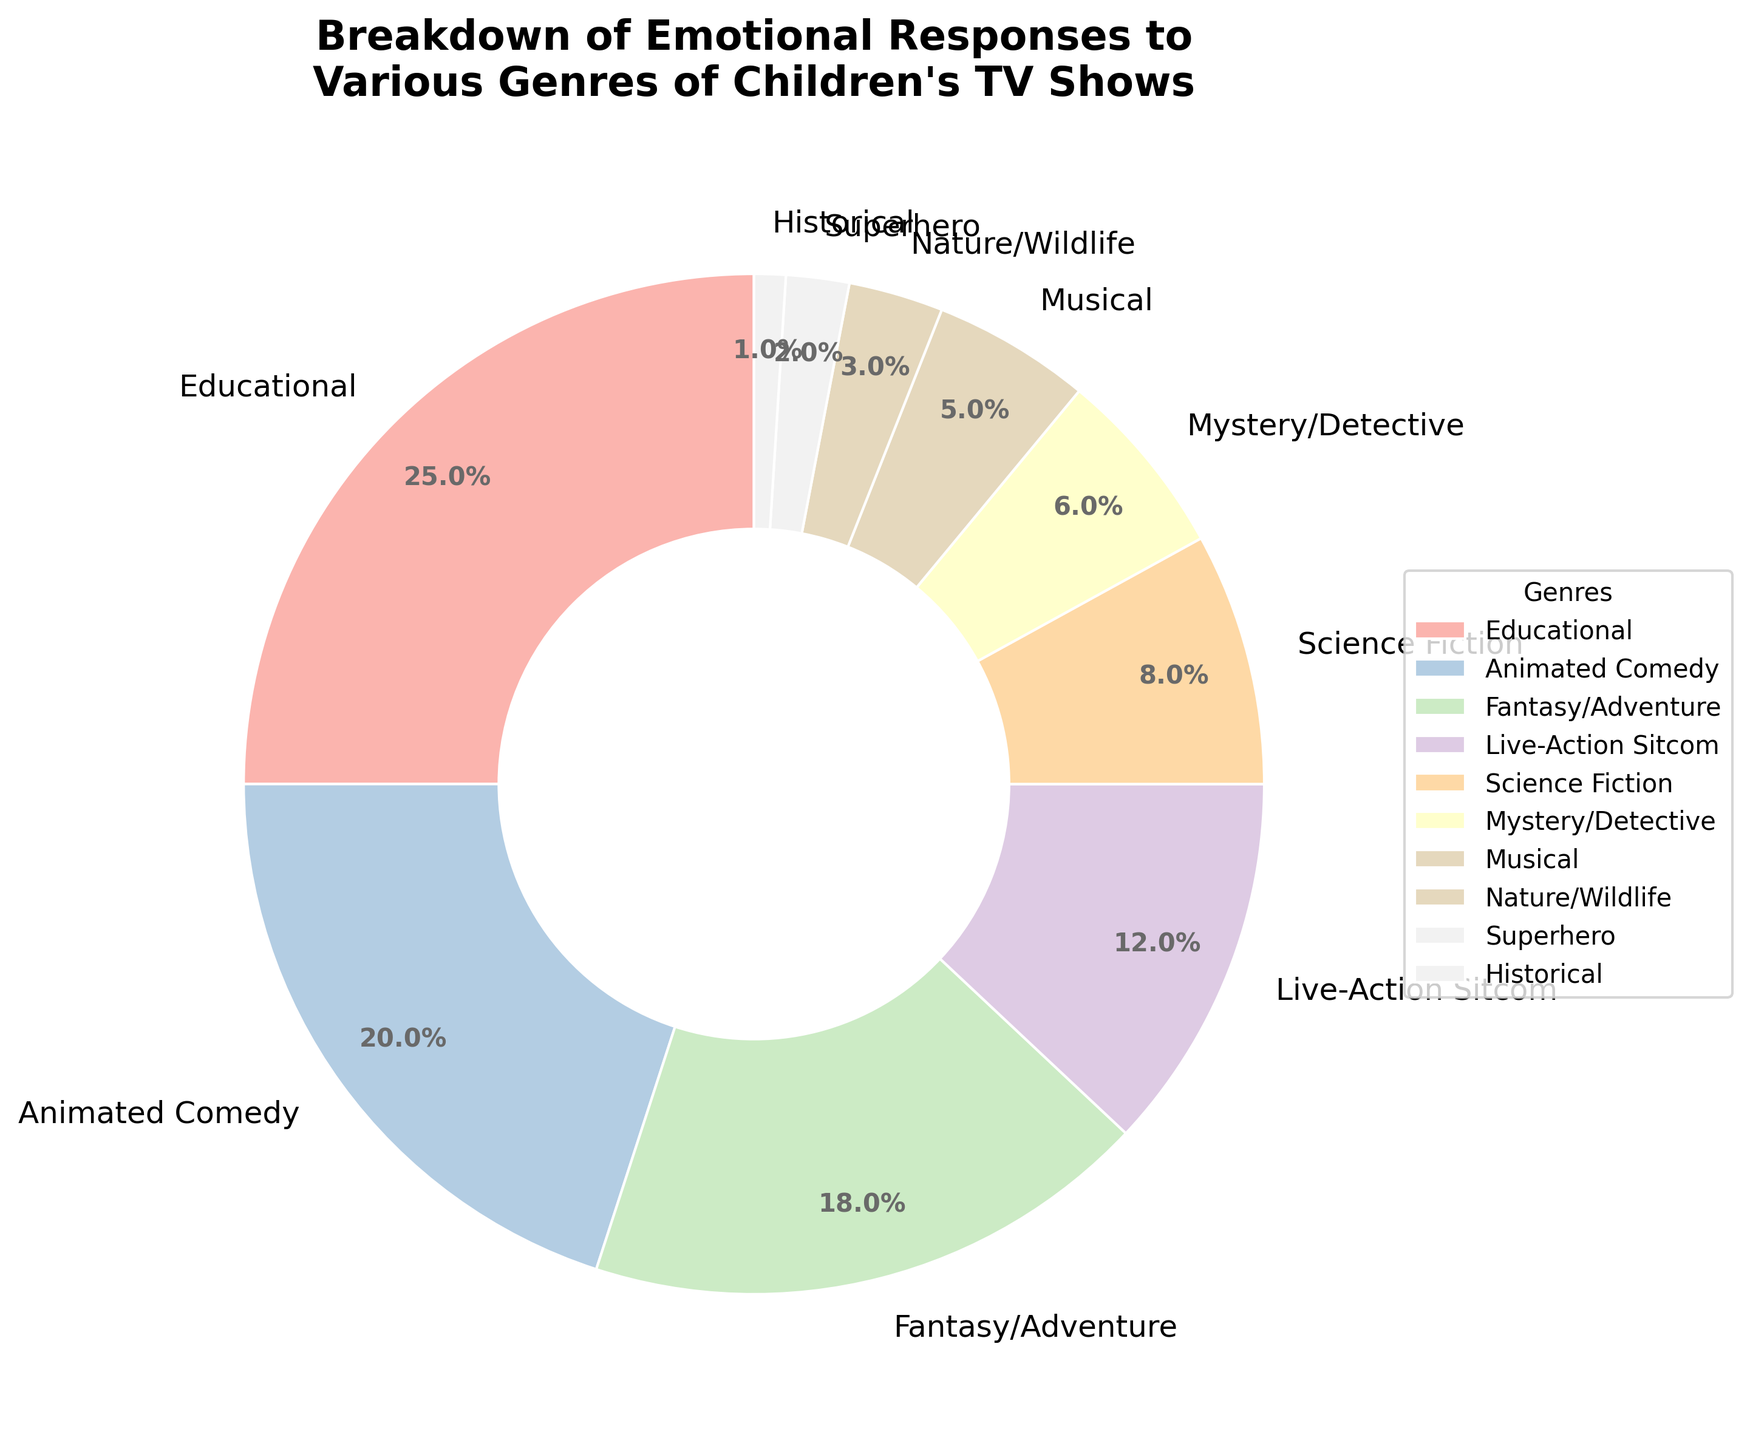What genre has the highest percentage of emotional responses? The pie chart shows the percentages of emotional responses for different genres. The largest wedge represents Educational TV shows.
Answer: Educational What are the top three genres in terms of emotional responses? The chart has wedges representing each genre with different percentages. The three largest wedges correspond to Educational, Animated Comedy, and Fantasy/Adventure.
Answer: Educational, Animated Comedy, Fantasy/Adventure What's the total percentage for the bottom three genres with the least emotional responses? The bottom three genres are Historical, Superhero, and Nature/Wildlife, with percentages of 1%, 2%, and 3% respectively. Summing these percentages: 1 + 2 + 3 = 6.
Answer: 6 Are there more emotional responses to Science Fiction or Live-Action Sitcom shows? Compare the percentages for Science Fiction (8%) and Live-Action Sitcom (12%) as provided in the pie chart. Live-Action Sitcom has a higher percentage.
Answer: Live-Action Sitcom What is the difference in emotional responses between Fantasy/Adventure and Musical genres? The pie chart indicates Fantasy/Adventure has 18% and Musical has 5%. Subtracting these values: 18 - 5 = 13.
Answer: 13 Which genres compose less than 10% of the total emotional responses? Identify wedges representing percentages below 10%: Science Fiction (8%), Mystery/Detective (6%), Musical (5%), Nature/Wildlife (3%), Superhero (2%), Historical (1%).
Answer: Science Fiction, Mystery/Detective, Musical, Nature/Wildlife, Superhero, Historical What is the combined percentage of emotional responses to Animated Comedy and Science Fiction? The pie chart shows Animated Comedy at 20% and Science Fiction at 8%. Summing these values: 20 + 8 = 28.
Answer: 28 Is the percentage for Fantasy/Adventure closer to Educational or Animated Comedy? Compare the Fantasy/Adventure percentage (18%) to Educational (25%) and Animated Comedy (20%). The difference between Fantasy/Adventure and Educational is 25 - 18 = 7. The difference between Fantasy/Adventure and Animated Comedy is 20 - 18 = 2. It is closer to Animated Comedy.
Answer: Animated Comedy 